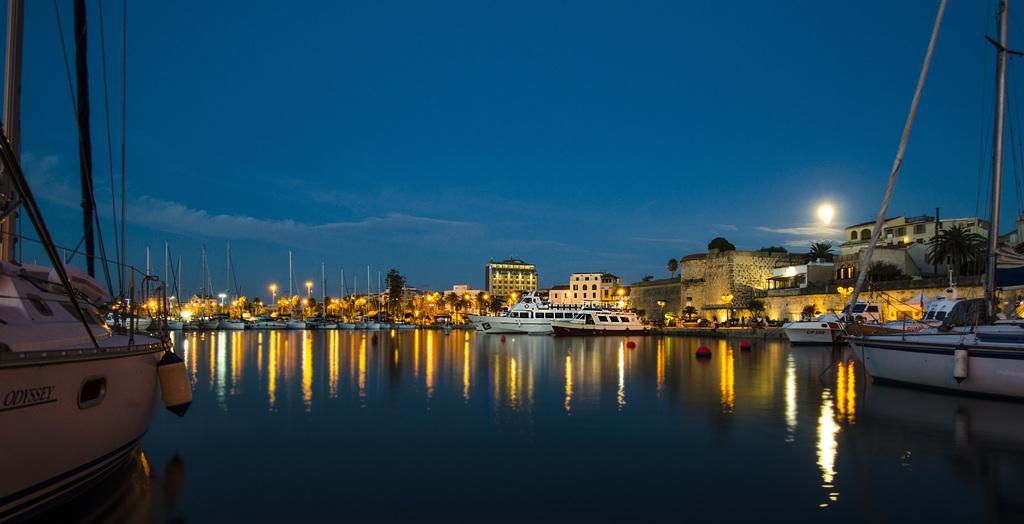Describe this image in one or two sentences. In this image we can see there are a few boats and ships in the river. On the left side of the image we can see few boats are on the side of a river. In the background of the image we can see there are so many buildings, lights, trees and sky. 